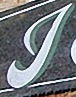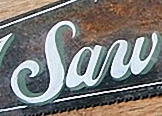Read the text from these images in sequence, separated by a semicolon. J; Saw 